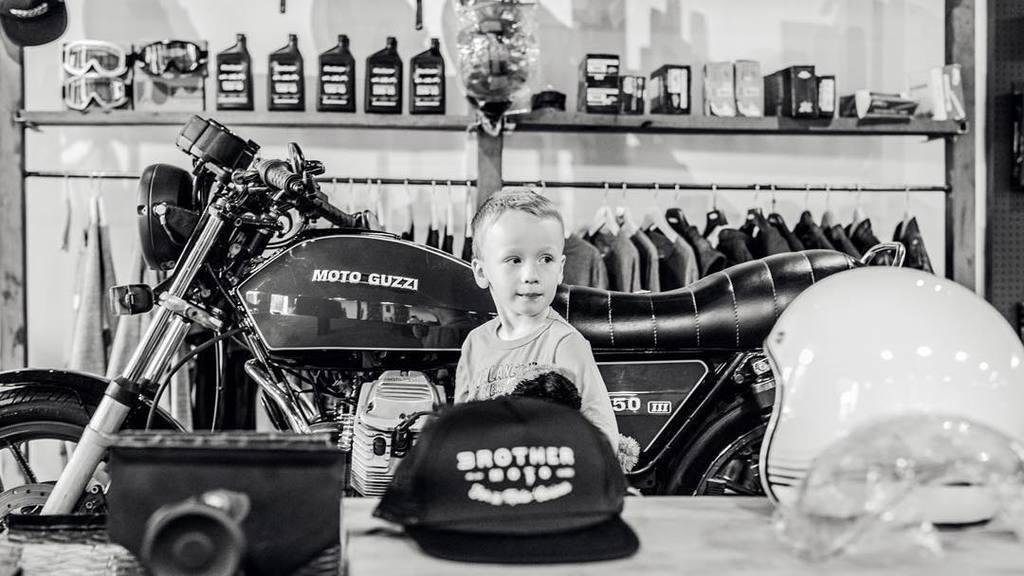How would you summarize this image in a sentence or two? This is a black and white picture, there is a boy standing in front of a bike, in the front there is a cap and helmet on a table, in the back there are bottles and jackets to hangers and on shelves. 